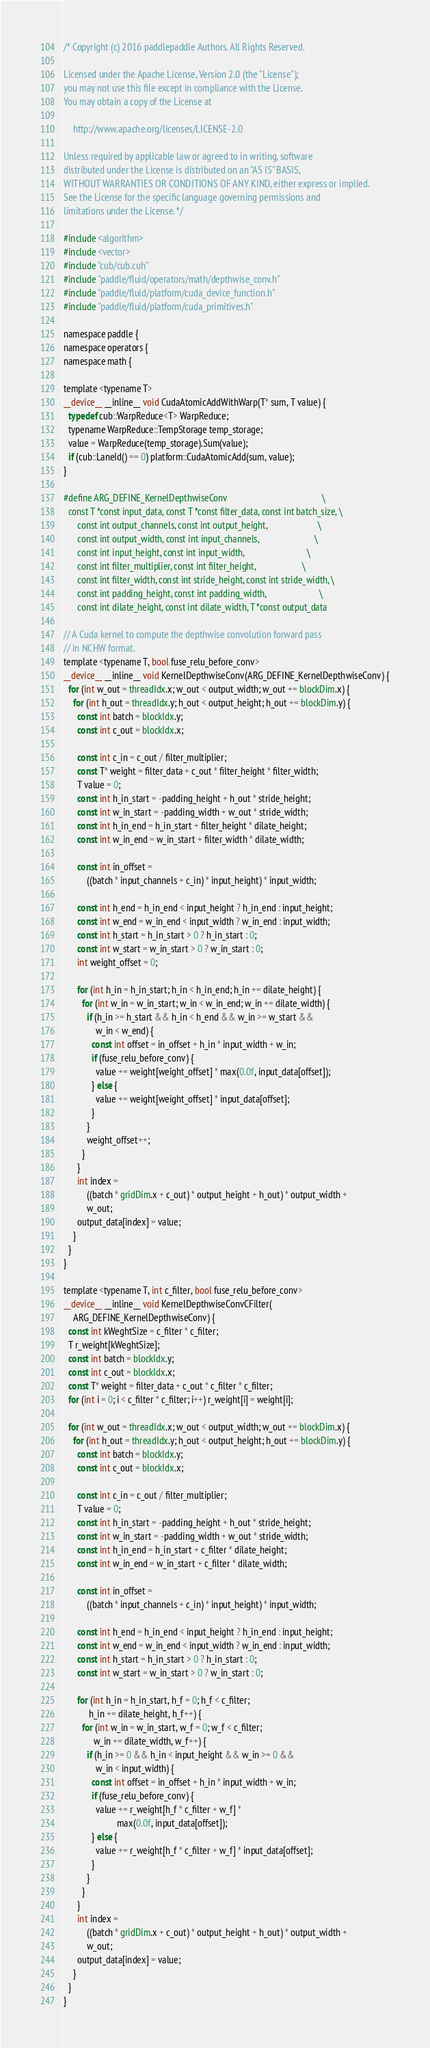<code> <loc_0><loc_0><loc_500><loc_500><_Cuda_>/* Copyright (c) 2016 paddlepaddle Authors. All Rights Reserved.

Licensed under the Apache License, Version 2.0 (the "License");
you may not use this file except in compliance with the License.
You may obtain a copy of the License at

    http://www.apache.org/licenses/LICENSE-2.0

Unless required by applicable law or agreed to in writing, software
distributed under the License is distributed on an "AS IS" BASIS,
WITHOUT WARRANTIES OR CONDITIONS OF ANY KIND, either express or implied.
See the License for the specific language governing permissions and
limitations under the License. */

#include <algorithm>
#include <vector>
#include "cub/cub.cuh"
#include "paddle/fluid/operators/math/depthwise_conv.h"
#include "paddle/fluid/platform/cuda_device_function.h"
#include "paddle/fluid/platform/cuda_primitives.h"

namespace paddle {
namespace operators {
namespace math {

template <typename T>
__device__ __inline__ void CudaAtomicAddWithWarp(T* sum, T value) {
  typedef cub::WarpReduce<T> WarpReduce;
  typename WarpReduce::TempStorage temp_storage;
  value = WarpReduce(temp_storage).Sum(value);
  if (cub::LaneId() == 0) platform::CudaAtomicAdd(sum, value);
}

#define ARG_DEFINE_KernelDepthwiseConv                                         \
  const T *const input_data, const T *const filter_data, const int batch_size, \
      const int output_channels, const int output_height,                      \
      const int output_width, const int input_channels,                        \
      const int input_height, const int input_width,                           \
      const int filter_multiplier, const int filter_height,                    \
      const int filter_width, const int stride_height, const int stride_width, \
      const int padding_height, const int padding_width,                       \
      const int dilate_height, const int dilate_width, T *const output_data

// A Cuda kernel to compute the depthwise convolution forward pass
// in NCHW format.
template <typename T, bool fuse_relu_before_conv>
__device__ __inline__ void KernelDepthwiseConv(ARG_DEFINE_KernelDepthwiseConv) {
  for (int w_out = threadIdx.x; w_out < output_width; w_out += blockDim.x) {
    for (int h_out = threadIdx.y; h_out < output_height; h_out += blockDim.y) {
      const int batch = blockIdx.y;
      const int c_out = blockIdx.x;

      const int c_in = c_out / filter_multiplier;
      const T* weight = filter_data + c_out * filter_height * filter_width;
      T value = 0;
      const int h_in_start = -padding_height + h_out * stride_height;
      const int w_in_start = -padding_width + w_out * stride_width;
      const int h_in_end = h_in_start + filter_height * dilate_height;
      const int w_in_end = w_in_start + filter_width * dilate_width;

      const int in_offset =
          ((batch * input_channels + c_in) * input_height) * input_width;

      const int h_end = h_in_end < input_height ? h_in_end : input_height;
      const int w_end = w_in_end < input_width ? w_in_end : input_width;
      const int h_start = h_in_start > 0 ? h_in_start : 0;
      const int w_start = w_in_start > 0 ? w_in_start : 0;
      int weight_offset = 0;

      for (int h_in = h_in_start; h_in < h_in_end; h_in += dilate_height) {
        for (int w_in = w_in_start; w_in < w_in_end; w_in += dilate_width) {
          if (h_in >= h_start && h_in < h_end && w_in >= w_start &&
              w_in < w_end) {
            const int offset = in_offset + h_in * input_width + w_in;
            if (fuse_relu_before_conv) {
              value += weight[weight_offset] * max(0.0f, input_data[offset]);
            } else {
              value += weight[weight_offset] * input_data[offset];
            }
          }
          weight_offset++;
        }
      }
      int index =
          ((batch * gridDim.x + c_out) * output_height + h_out) * output_width +
          w_out;
      output_data[index] = value;
    }
  }
}

template <typename T, int c_filter, bool fuse_relu_before_conv>
__device__ __inline__ void KernelDepthwiseConvCFilter(
    ARG_DEFINE_KernelDepthwiseConv) {
  const int kWeghtSize = c_filter * c_filter;
  T r_weight[kWeghtSize];
  const int batch = blockIdx.y;
  const int c_out = blockIdx.x;
  const T* weight = filter_data + c_out * c_filter * c_filter;
  for (int i = 0; i < c_filter * c_filter; i++) r_weight[i] = weight[i];

  for (int w_out = threadIdx.x; w_out < output_width; w_out += blockDim.x) {
    for (int h_out = threadIdx.y; h_out < output_height; h_out += blockDim.y) {
      const int batch = blockIdx.y;
      const int c_out = blockIdx.x;

      const int c_in = c_out / filter_multiplier;
      T value = 0;
      const int h_in_start = -padding_height + h_out * stride_height;
      const int w_in_start = -padding_width + w_out * stride_width;
      const int h_in_end = h_in_start + c_filter * dilate_height;
      const int w_in_end = w_in_start + c_filter * dilate_width;

      const int in_offset =
          ((batch * input_channels + c_in) * input_height) * input_width;

      const int h_end = h_in_end < input_height ? h_in_end : input_height;
      const int w_end = w_in_end < input_width ? w_in_end : input_width;
      const int h_start = h_in_start > 0 ? h_in_start : 0;
      const int w_start = w_in_start > 0 ? w_in_start : 0;

      for (int h_in = h_in_start, h_f = 0; h_f < c_filter;
           h_in += dilate_height, h_f++) {
        for (int w_in = w_in_start, w_f = 0; w_f < c_filter;
             w_in += dilate_width, w_f++) {
          if (h_in >= 0 && h_in < input_height && w_in >= 0 &&
              w_in < input_width) {
            const int offset = in_offset + h_in * input_width + w_in;
            if (fuse_relu_before_conv) {
              value += r_weight[h_f * c_filter + w_f] *
                       max(0.0f, input_data[offset]);
            } else {
              value += r_weight[h_f * c_filter + w_f] * input_data[offset];
            }
          }
        }
      }
      int index =
          ((batch * gridDim.x + c_out) * output_height + h_out) * output_width +
          w_out;
      output_data[index] = value;
    }
  }
}
</code> 